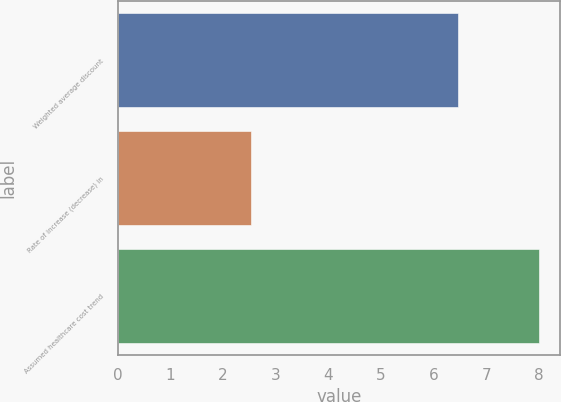Convert chart to OTSL. <chart><loc_0><loc_0><loc_500><loc_500><bar_chart><fcel>Weighted average discount<fcel>Rate of increase (decrease) in<fcel>Assumed healthcare cost trend<nl><fcel>6.46<fcel>2.53<fcel>8<nl></chart> 